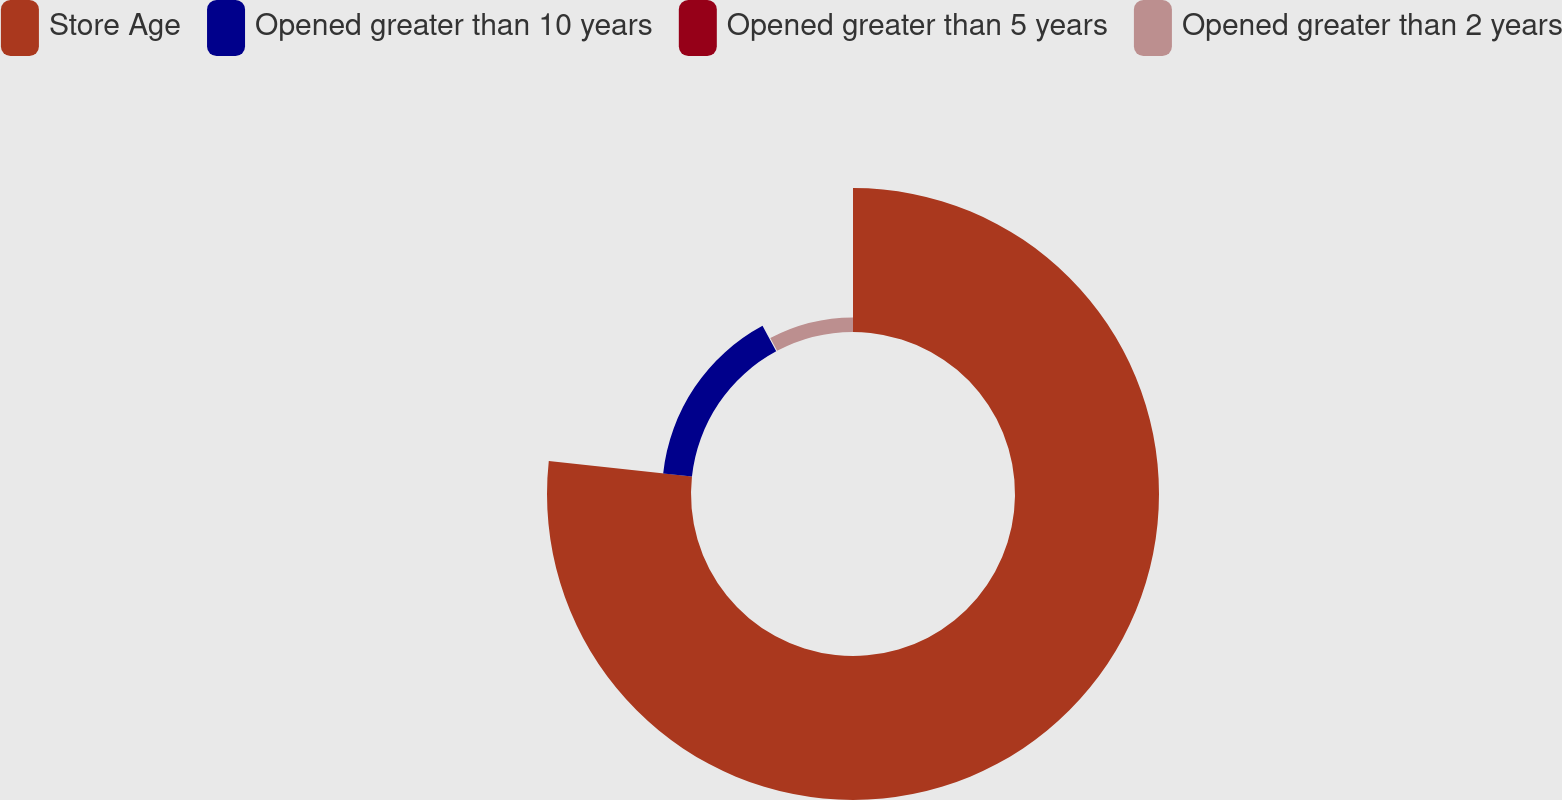Convert chart. <chart><loc_0><loc_0><loc_500><loc_500><pie_chart><fcel>Store Age<fcel>Opened greater than 10 years<fcel>Opened greater than 5 years<fcel>Opened greater than 2 years<nl><fcel>76.73%<fcel>15.42%<fcel>0.1%<fcel>7.76%<nl></chart> 